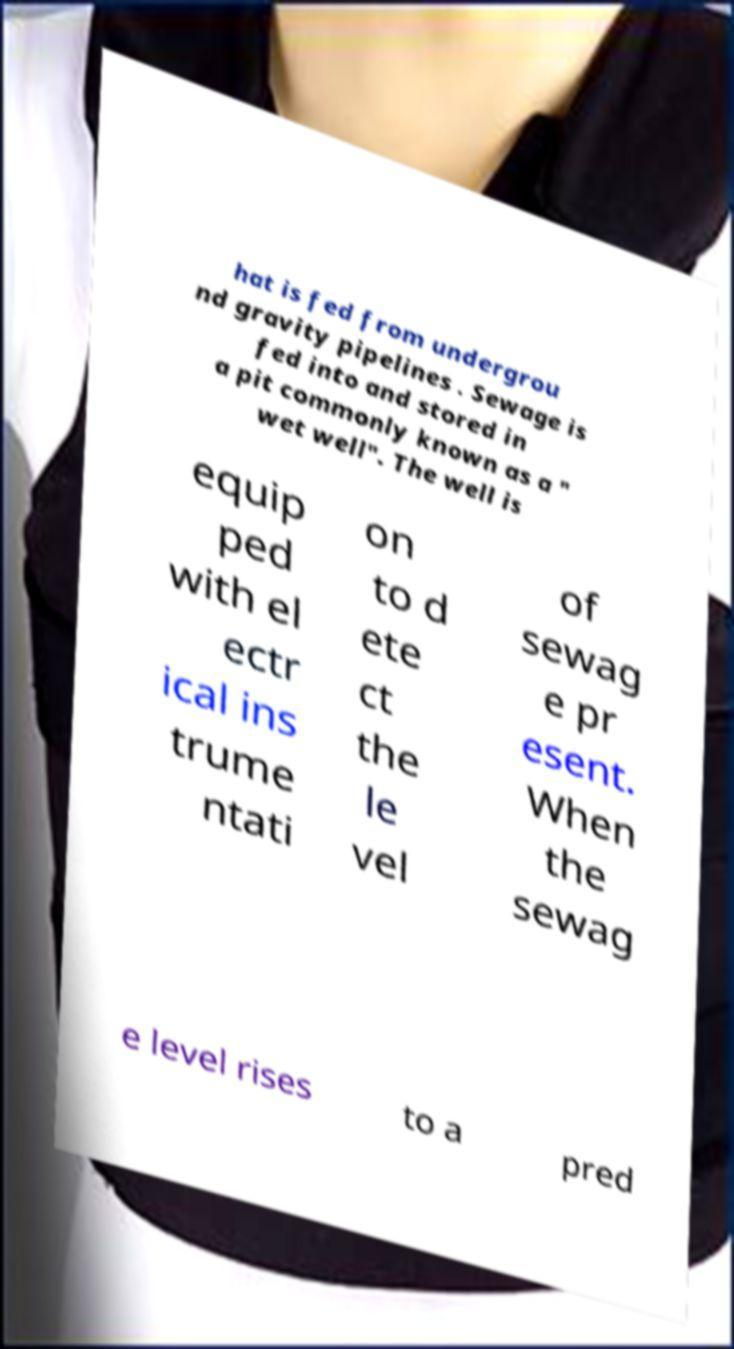Please identify and transcribe the text found in this image. hat is fed from undergrou nd gravity pipelines . Sewage is fed into and stored in a pit commonly known as a " wet well". The well is equip ped with el ectr ical ins trume ntati on to d ete ct the le vel of sewag e pr esent. When the sewag e level rises to a pred 